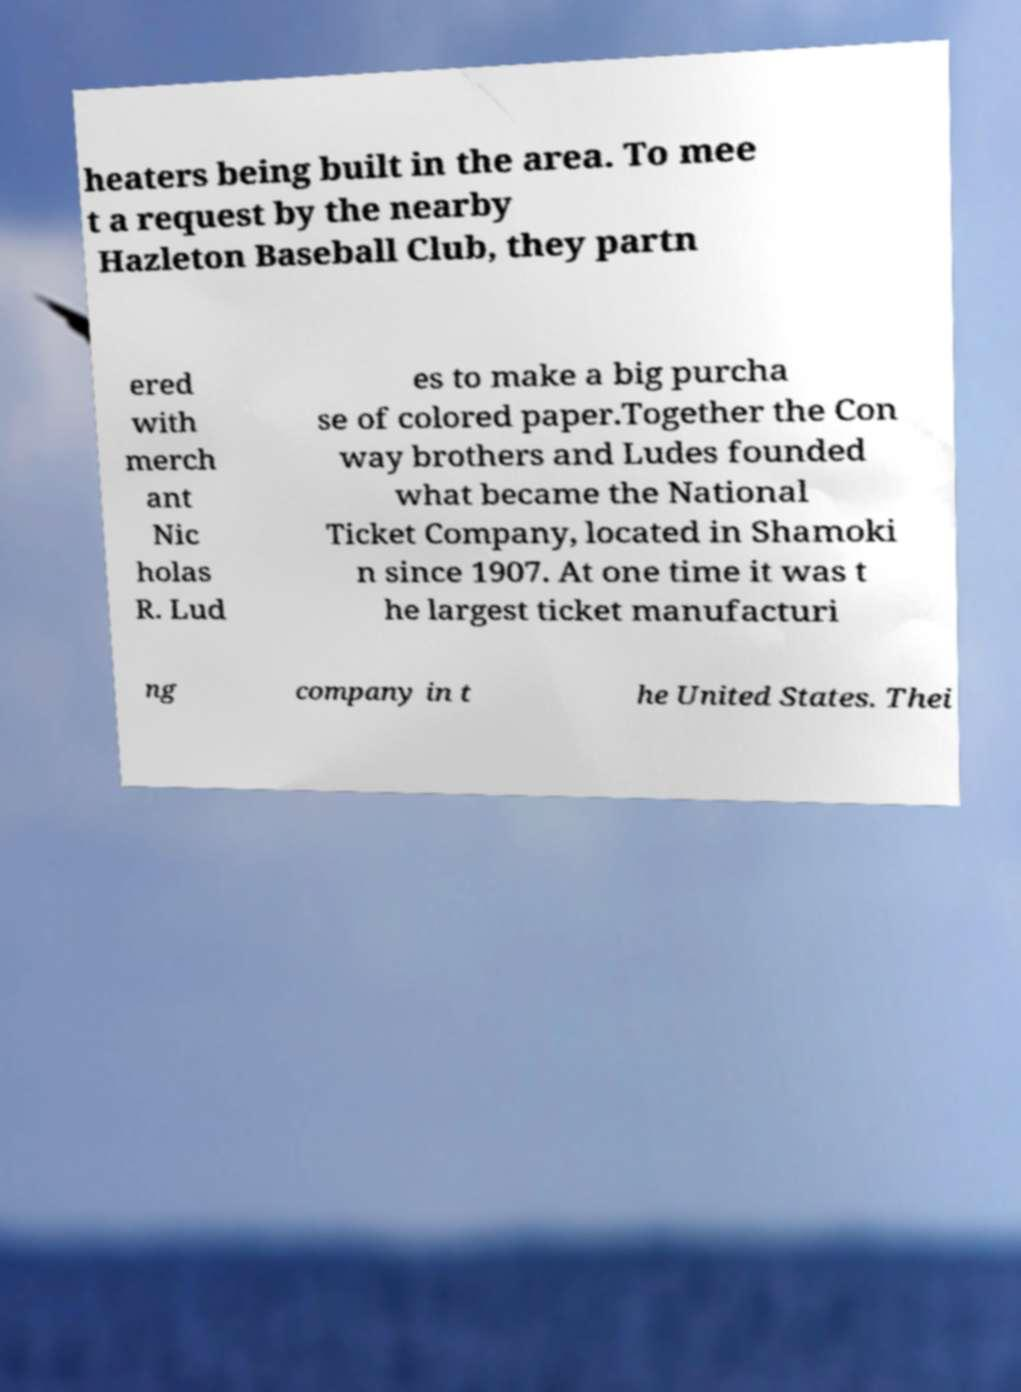Could you assist in decoding the text presented in this image and type it out clearly? heaters being built in the area. To mee t a request by the nearby Hazleton Baseball Club, they partn ered with merch ant Nic holas R. Lud es to make a big purcha se of colored paper.Together the Con way brothers and Ludes founded what became the National Ticket Company, located in Shamoki n since 1907. At one time it was t he largest ticket manufacturi ng company in t he United States. Thei 